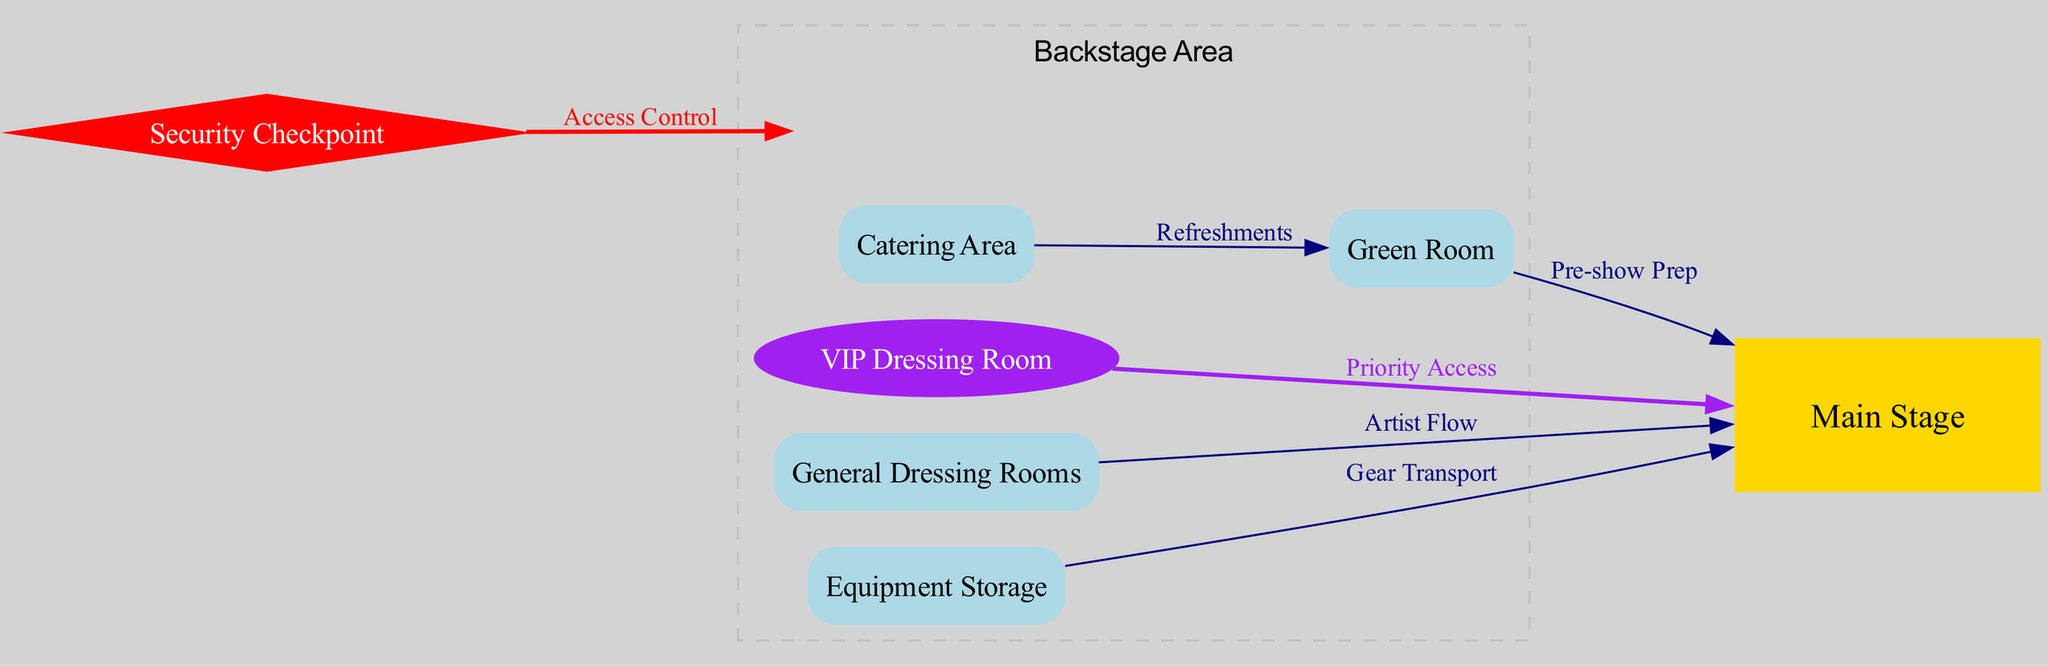What is the label of the node connected to the general dressing rooms? The edge from the "general_dressing_rooms" node points to the "main_stage" node, indicating that the label of the node connected to it is "Main Stage".
Answer: Main Stage How many dressing rooms are shown in the diagram? The diagram features two types of dressing rooms: "VIP Dressing Room" and "General Dressing Rooms", making a total of two dressing room nodes.
Answer: 2 What type of access does the VIP Dressing Room have? The edge from "vip_dressing_room" to "main_stage" is labeled "Priority Access", indicating that this dressing room has priority access.
Answer: Priority Access Which area provides refreshments to the Green Room? The edge from "catering_area" to "green_room" is labeled "Refreshments", showing that the catering area provides refreshments to the Green Room.
Answer: Catering Area What is the purpose of the equipment storage in relation to the main stage? The edge from "equipment_storage" to "main_stage" is labeled "Gear Transport", indicating that the purpose of equipment storage is to facilitate the transport of gear to the main stage.
Answer: Gear Transport What controls access to the backstage area? The edge from "security_checkpoint" to "backstage_area" is labeled "Access Control", meaning that access to the backstage area is controlled through the security checkpoint.
Answer: Access Control Which room is designated for pre-show preparation? The edge from "green_room" to "main_stage" is labeled "Pre-show Prep", which indicates that the Green Room is designated for pre-show preparation.
Answer: Green Room How many nodes are classified as storage areas in the diagram? The only storage area specified in the diagram is the "Equipment Storage", giving us one node classified as a storage area.
Answer: 1 What connects the catering area to the green room? The diagram shows an edge labeled "Refreshments" connecting the "catering_area" to the "green_room", indicating the connection type.
Answer: Refreshments 